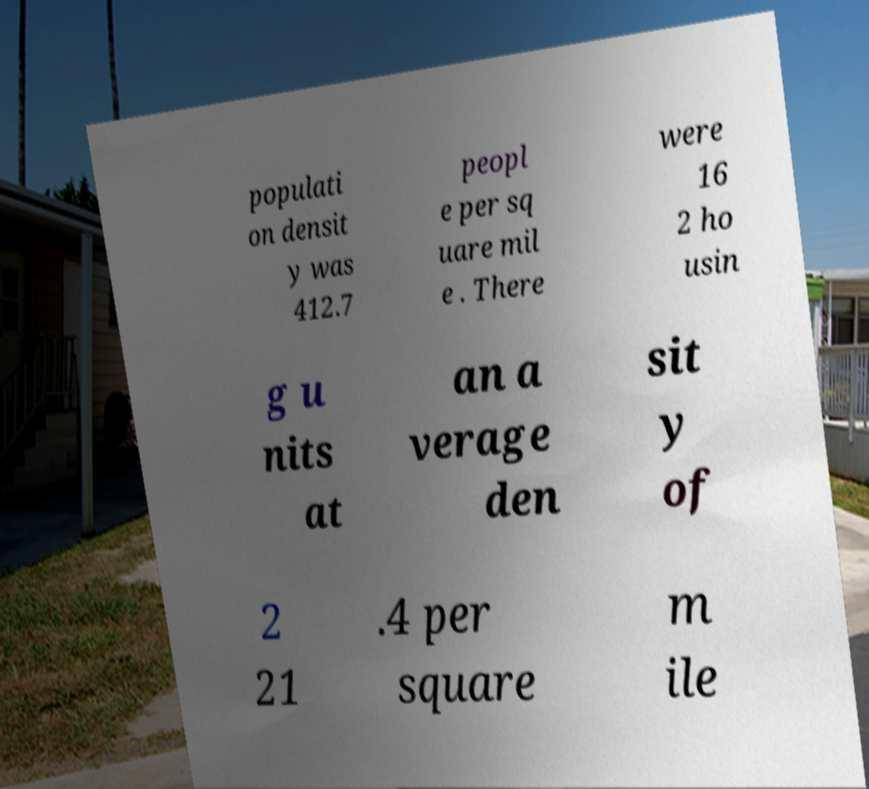Can you accurately transcribe the text from the provided image for me? populati on densit y was 412.7 peopl e per sq uare mil e . There were 16 2 ho usin g u nits at an a verage den sit y of 2 21 .4 per square m ile 